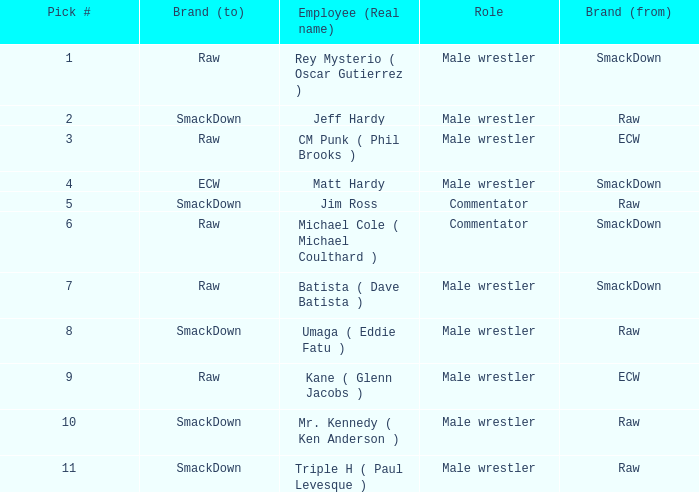What role did Pick # 10 have? Male wrestler. 